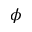Convert formula to latex. <formula><loc_0><loc_0><loc_500><loc_500>\phi</formula> 